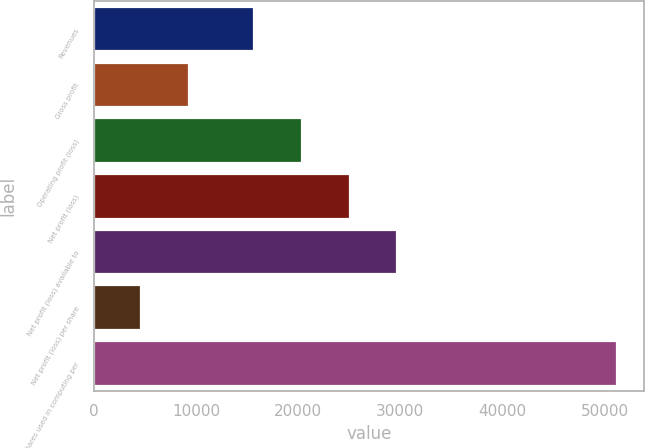Convert chart to OTSL. <chart><loc_0><loc_0><loc_500><loc_500><bar_chart><fcel>Revenues<fcel>Gross profit<fcel>Operating profit (loss)<fcel>Net profit (loss)<fcel>Net profit (loss) available to<fcel>Net profit (loss) per share<fcel>Shares used in computing per<nl><fcel>15714<fcel>9315.56<fcel>20371.6<fcel>25029.1<fcel>29686.7<fcel>4658<fcel>51233.6<nl></chart> 